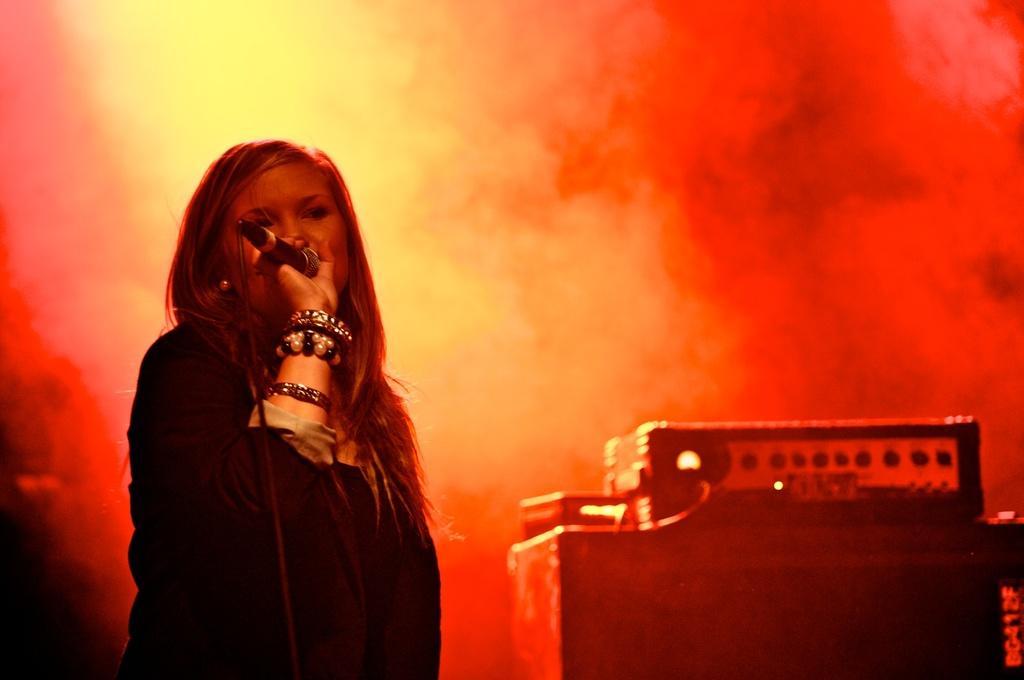Could you give a brief overview of what you see in this image? This picture shows a woman standing and singing with the help of a microphone holding in her hand 